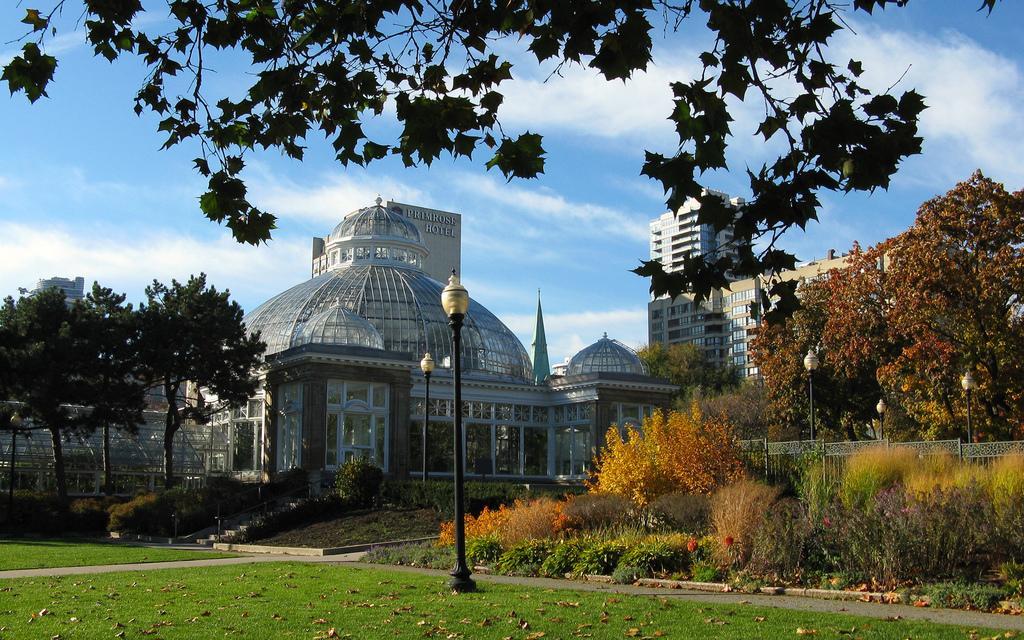In one or two sentences, can you explain what this image depicts? In this image we can see some plants, trees and grass on the ground and we can see some dry leaves. There are some building and pole lights and at the top we can see the sky with clouds. 